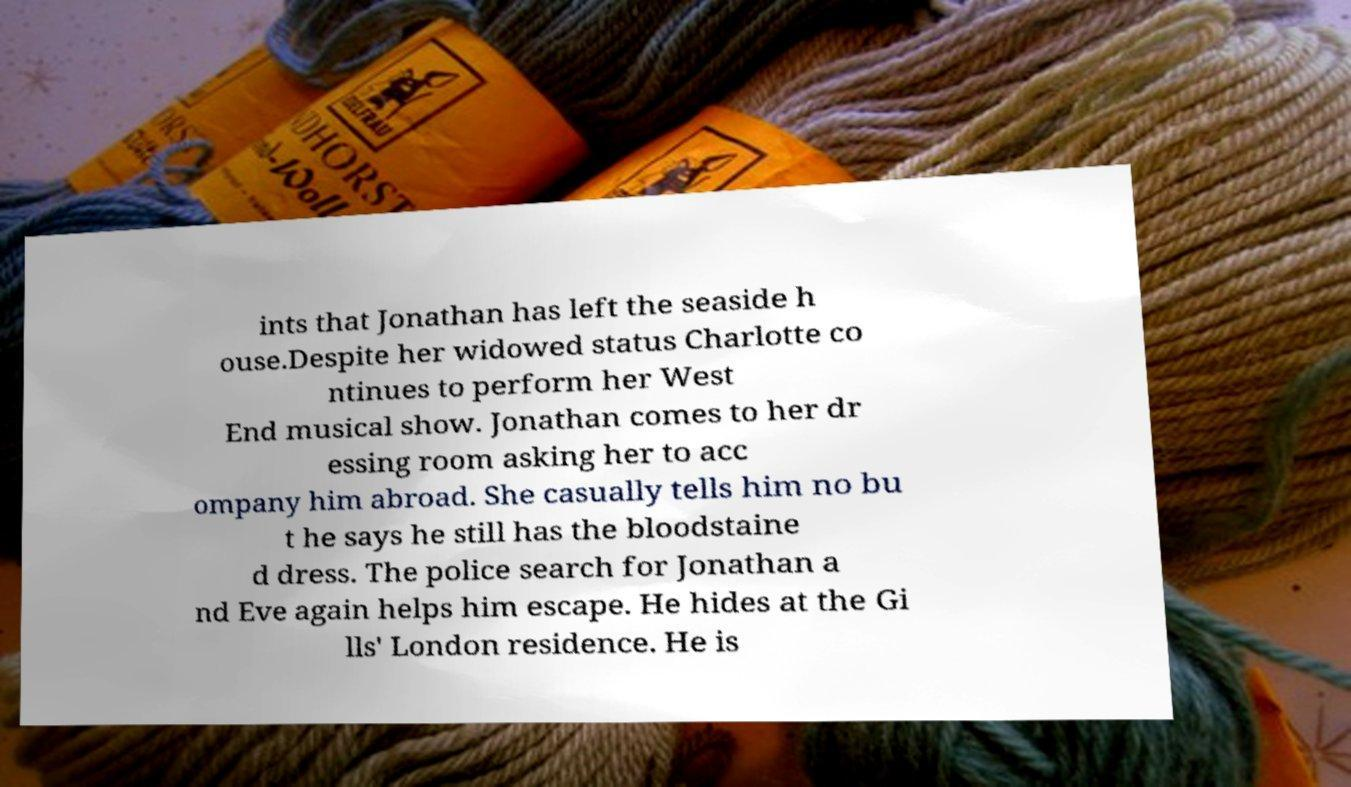Please identify and transcribe the text found in this image. ints that Jonathan has left the seaside h ouse.Despite her widowed status Charlotte co ntinues to perform her West End musical show. Jonathan comes to her dr essing room asking her to acc ompany him abroad. She casually tells him no bu t he says he still has the bloodstaine d dress. The police search for Jonathan a nd Eve again helps him escape. He hides at the Gi lls' London residence. He is 